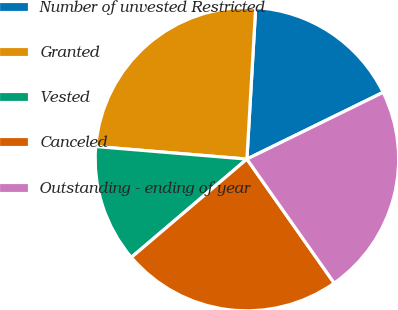Convert chart. <chart><loc_0><loc_0><loc_500><loc_500><pie_chart><fcel>Number of unvested Restricted<fcel>Granted<fcel>Vested<fcel>Canceled<fcel>Outstanding - ending of year<nl><fcel>16.83%<fcel>24.6%<fcel>12.54%<fcel>23.54%<fcel>22.49%<nl></chart> 